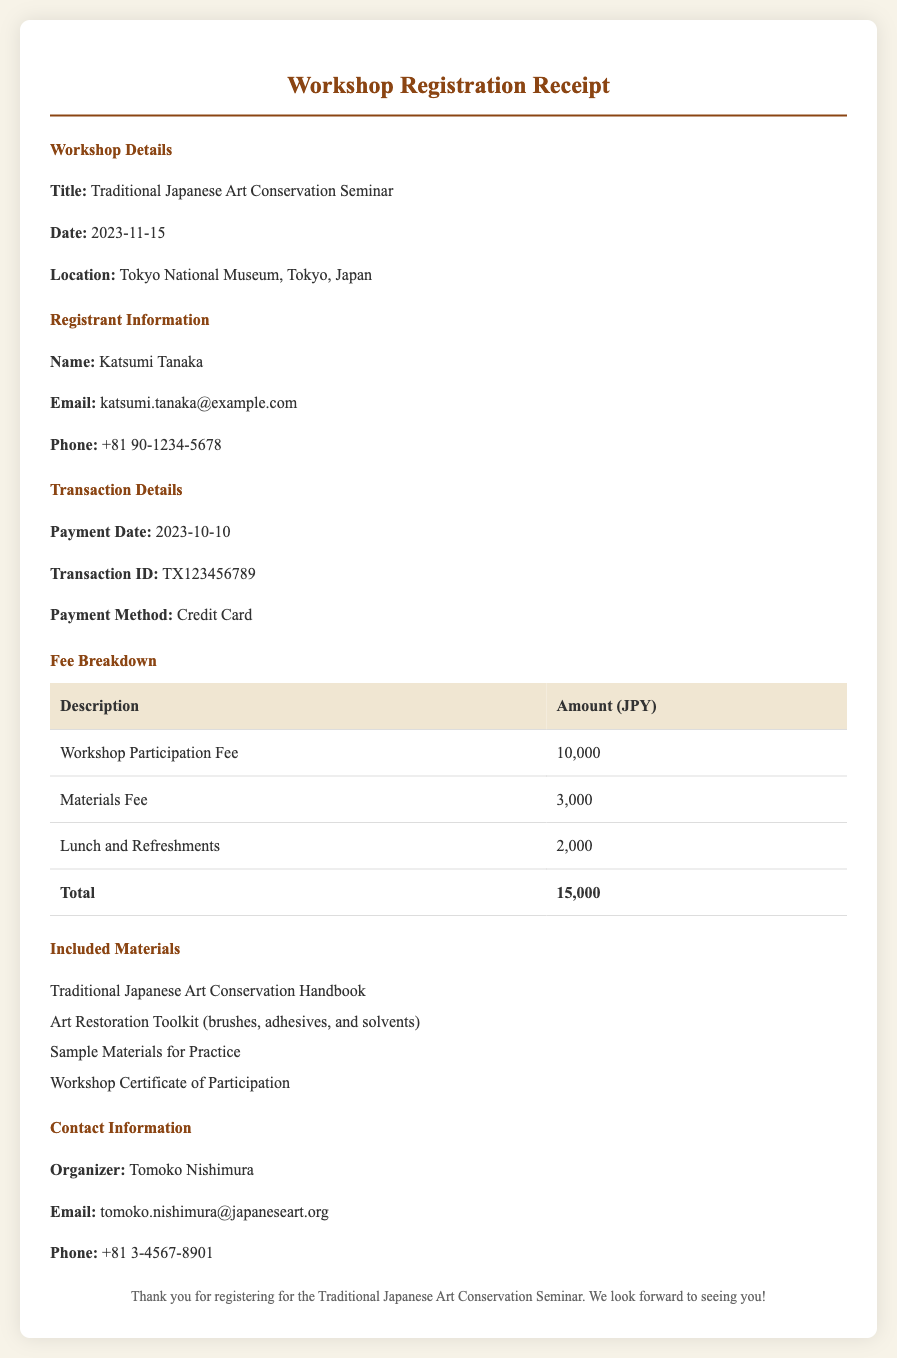what is the title of the workshop? The title of the workshop is stated in the workshop details section.
Answer: Traditional Japanese Art Conservation Seminar what is the date of the seminar? The date of the seminar is mentioned in the workshop details section.
Answer: 2023-11-15 who is the registrant? The registrant's name is listed in the registrant information section.
Answer: Katsumi Tanaka what is the total fee for the workshop? The total fee is found in the fee breakdown table under total.
Answer: 15,000 how much is the materials fee? The materials fee is explicitly mentioned in the fee breakdown section.
Answer: 3,000 what included material is for practice? Included materials consist of specific items listed in the included materials section.
Answer: Sample Materials for Practice who is the organizer of the workshop? The organizer's name is provided in the contact information section.
Answer: Tomoko Nishimura what payment method was used? The payment method is indicated in the transaction details section.
Answer: Credit Card what is the contact email of the organizer? The organizer's email is located in the contact information section.
Answer: tomoko.nishimura@japaneseart.org 